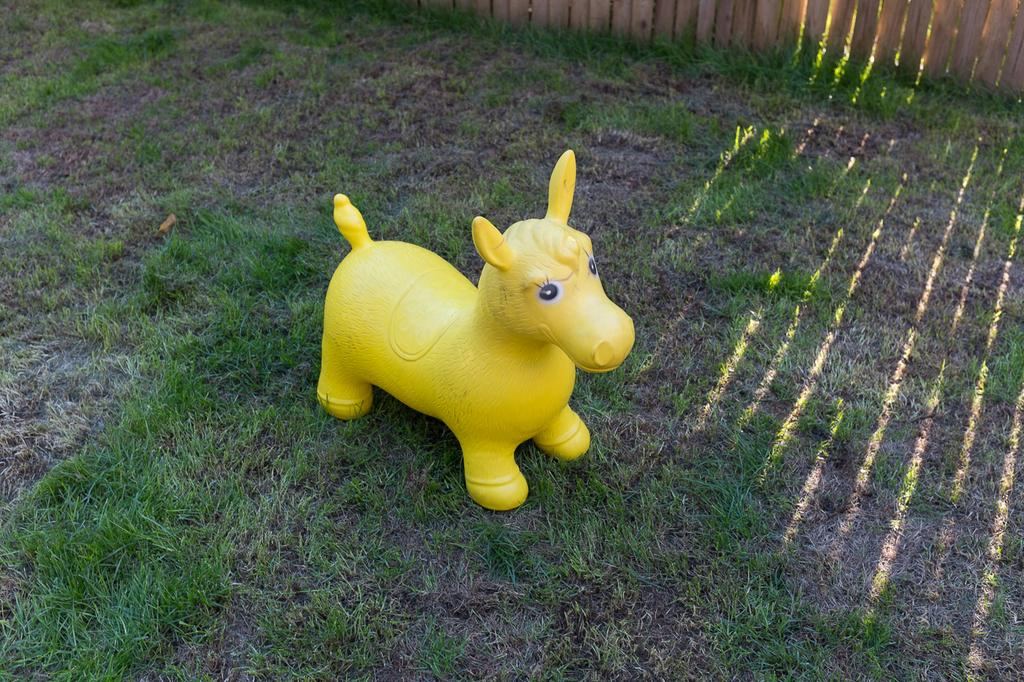What type of object can be seen on the grass in the image? There is a toy present on the surface of the grass. What material is used for the fencing at the top of the image? The wooden fencing is at the top of the image. How many teeth can be seen in the frame of the image? There are no teeth or frames present in the image; it features a toy on the grass and wooden fencing. 